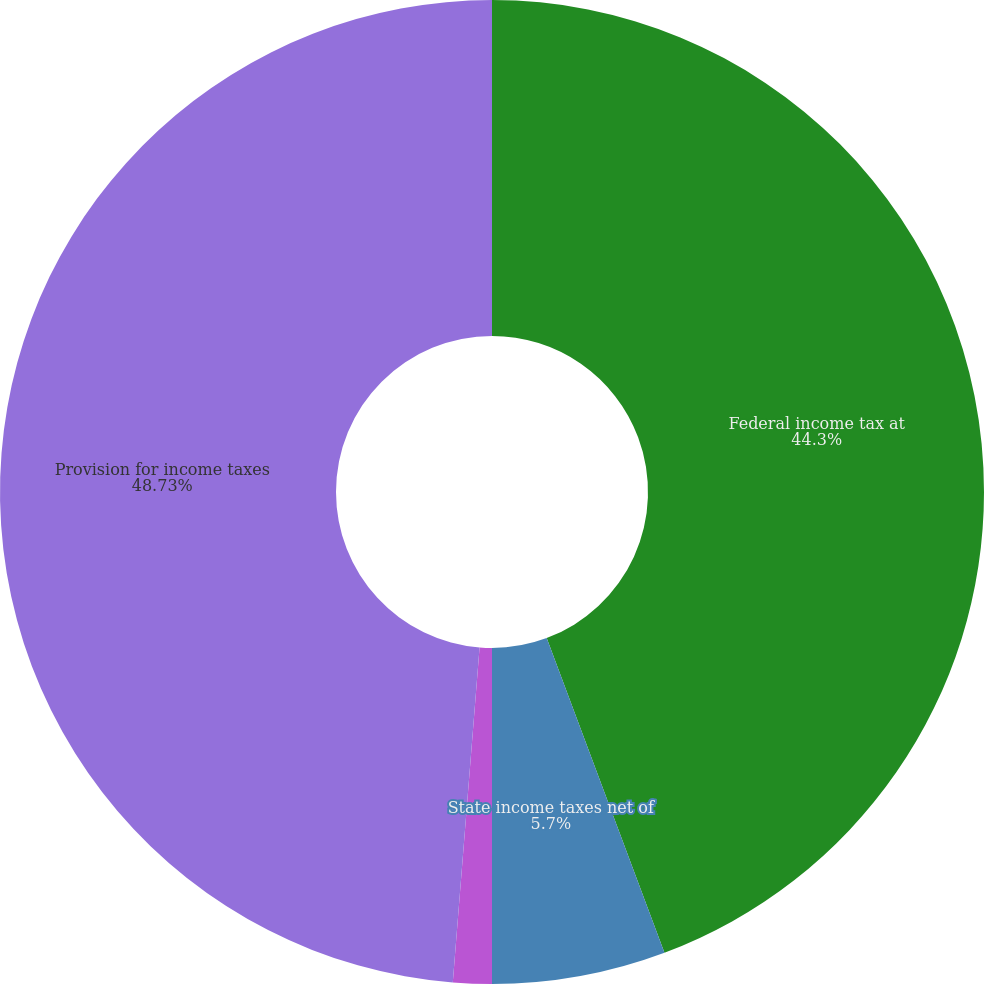<chart> <loc_0><loc_0><loc_500><loc_500><pie_chart><fcel>Federal income tax at<fcel>State income taxes net of<fcel>Other net<fcel>Provision for income taxes<nl><fcel>44.3%<fcel>5.7%<fcel>1.27%<fcel>48.73%<nl></chart> 